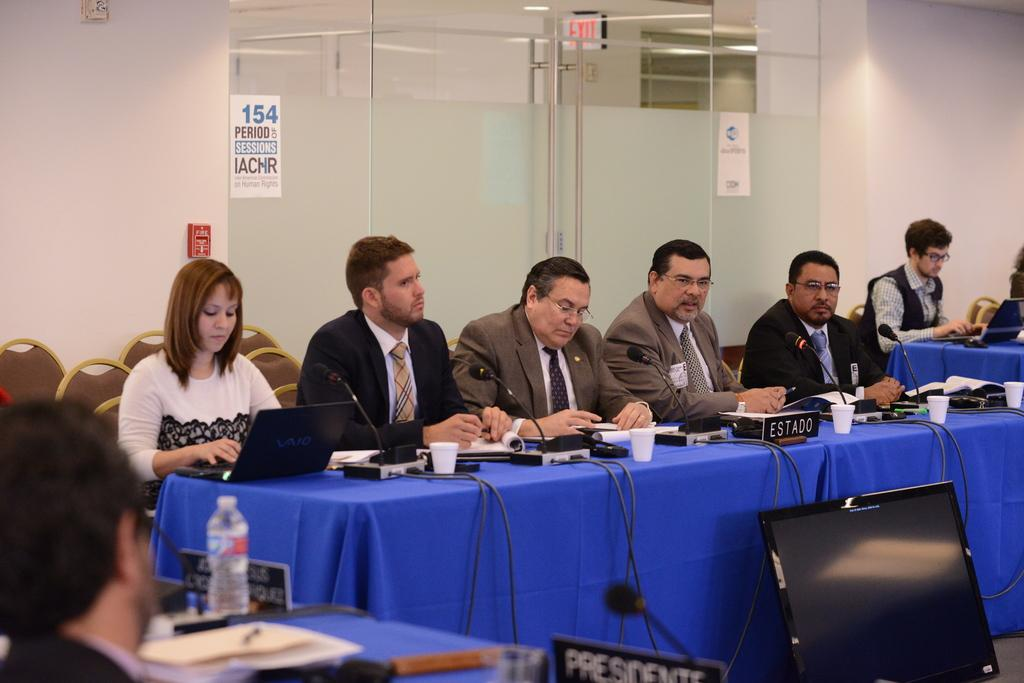<image>
Describe the image concisely. A table with 5 people on it that has a ESTADO sign near the front. 